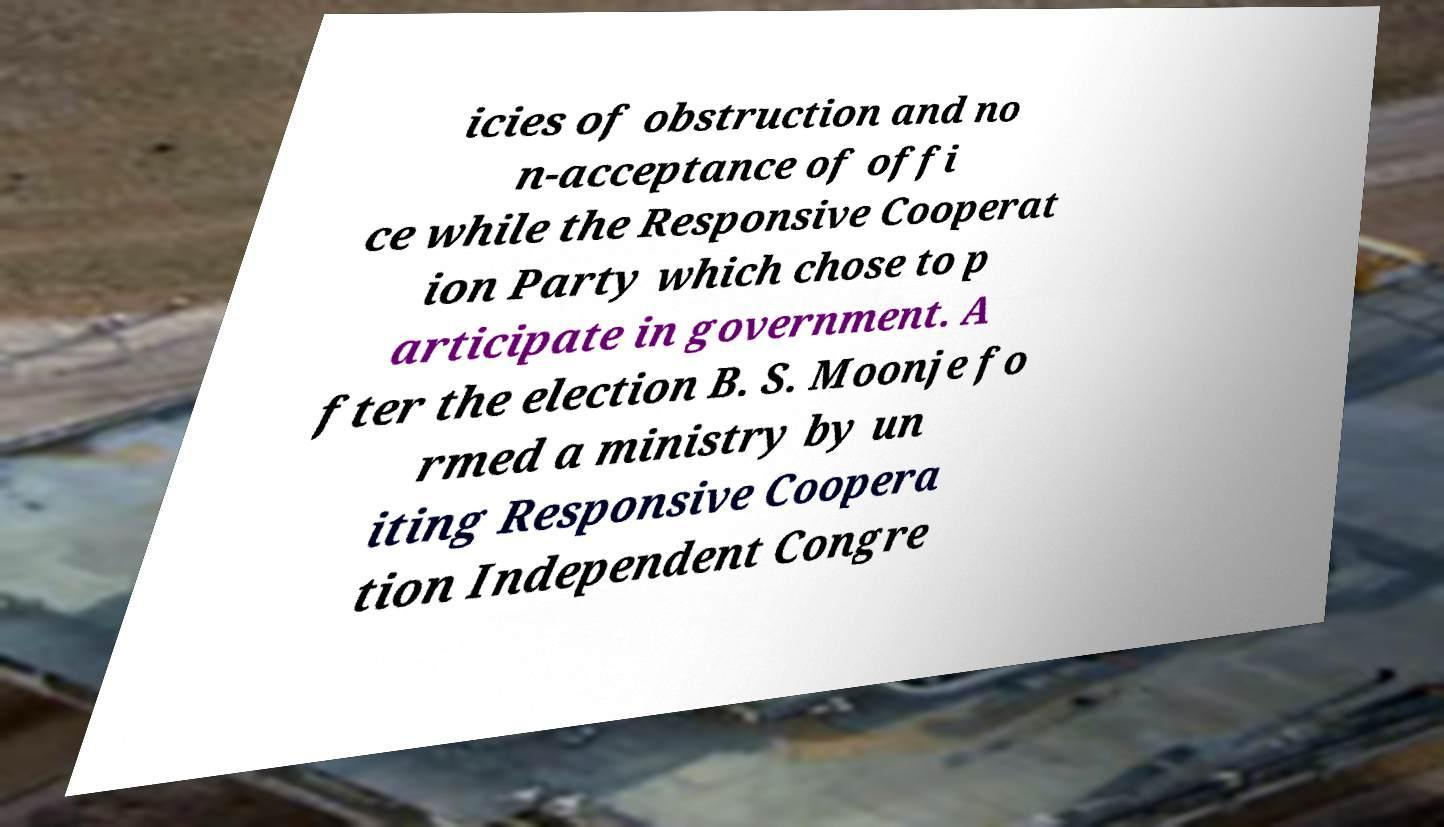Please identify and transcribe the text found in this image. icies of obstruction and no n-acceptance of offi ce while the Responsive Cooperat ion Party which chose to p articipate in government. A fter the election B. S. Moonje fo rmed a ministry by un iting Responsive Coopera tion Independent Congre 